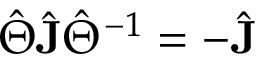<formula> <loc_0><loc_0><loc_500><loc_500>\hat { \Theta } \hat { J } \hat { \Theta } ^ { - 1 } = - \hat { J }</formula> 